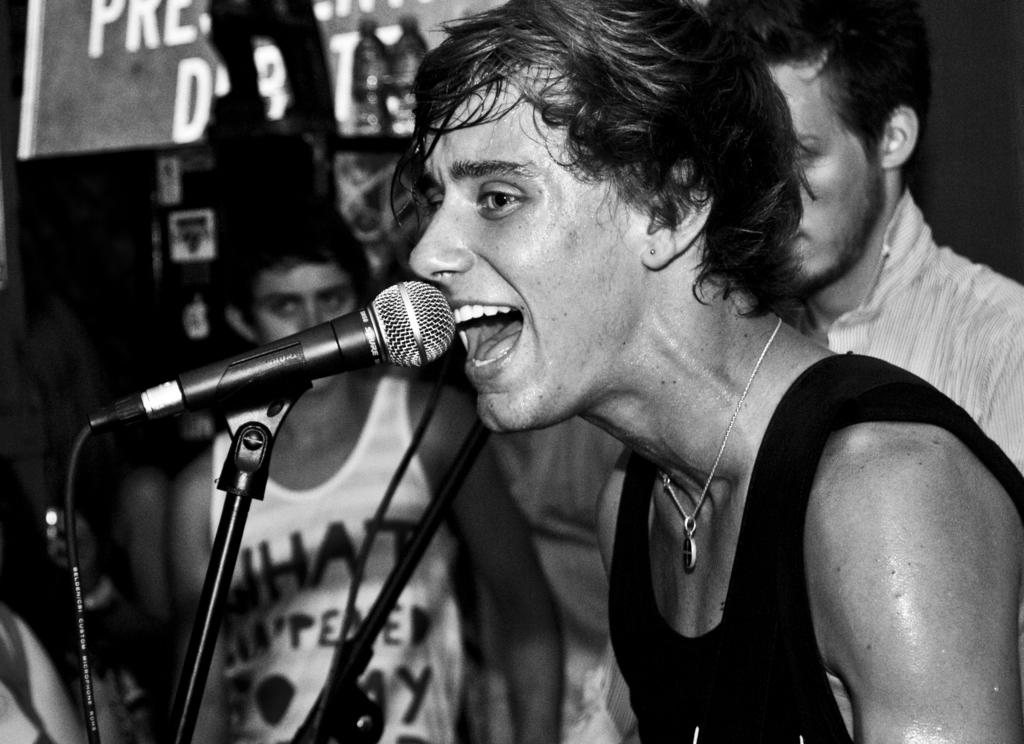Who is the main subject in the image? There is a boy in the image. What is the boy wearing? The boy is wearing a black sleeveless shirt. What is the boy doing in the image? The boy is singing. What can be seen in the boy's hand? There is a black microphone in the image. How many other boys are present in the image? There are two boys behind the singer. What are the two boys doing? The two boys are looking at the camera. What type of beds can be seen in the image? There are no beds present in the image. Is there a nest visible in the image? There is no nest visible in the image. 